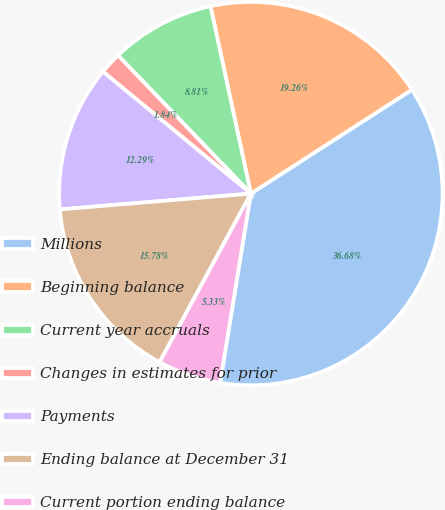Convert chart. <chart><loc_0><loc_0><loc_500><loc_500><pie_chart><fcel>Millions<fcel>Beginning balance<fcel>Current year accruals<fcel>Changes in estimates for prior<fcel>Payments<fcel>Ending balance at December 31<fcel>Current portion ending balance<nl><fcel>36.68%<fcel>19.26%<fcel>8.81%<fcel>1.84%<fcel>12.29%<fcel>15.78%<fcel>5.33%<nl></chart> 